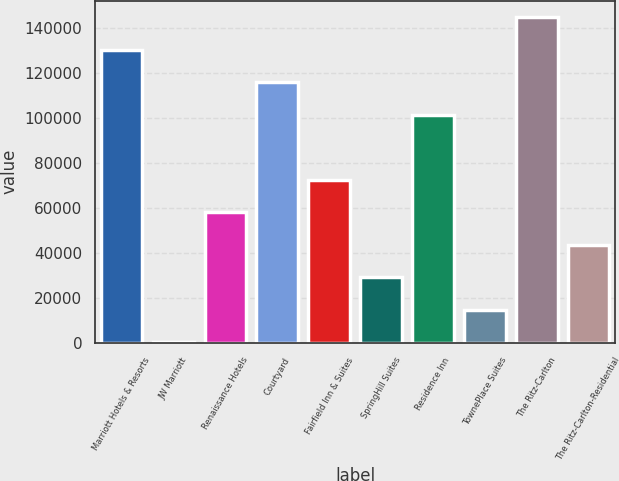Convert chart to OTSL. <chart><loc_0><loc_0><loc_500><loc_500><bar_chart><fcel>Marriott Hotels & Resorts<fcel>JW Marriott<fcel>Renaissance Hotels<fcel>Courtyard<fcel>Fairfield Inn & Suites<fcel>SpringHill Suites<fcel>Residence Inn<fcel>TownePlace Suites<fcel>The Ritz-Carlton<fcel>The Ritz-Carlton-Residential<nl><fcel>130556<fcel>221<fcel>58147.8<fcel>116075<fcel>72629.5<fcel>29184.4<fcel>101593<fcel>14702.7<fcel>145038<fcel>43666.1<nl></chart> 